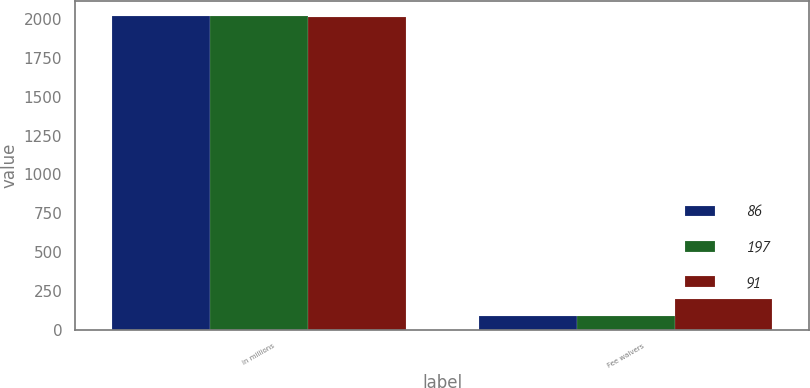Convert chart to OTSL. <chart><loc_0><loc_0><loc_500><loc_500><stacked_bar_chart><ecel><fcel>in millions<fcel>Fee waivers<nl><fcel>86<fcel>2017<fcel>86<nl><fcel>197<fcel>2016<fcel>91<nl><fcel>91<fcel>2015<fcel>197<nl></chart> 